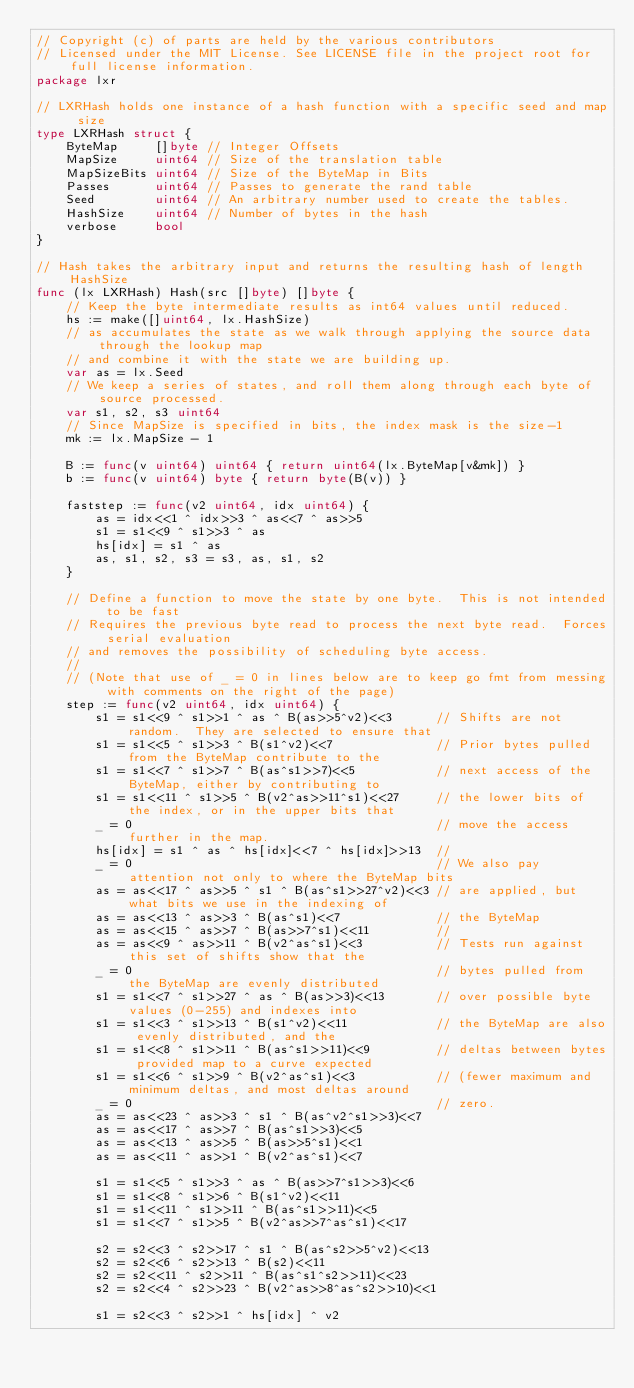Convert code to text. <code><loc_0><loc_0><loc_500><loc_500><_Go_>// Copyright (c) of parts are held by the various contributors
// Licensed under the MIT License. See LICENSE file in the project root for full license information.
package lxr

// LXRHash holds one instance of a hash function with a specific seed and map size
type LXRHash struct {
	ByteMap     []byte // Integer Offsets
	MapSize     uint64 // Size of the translation table
	MapSizeBits uint64 // Size of the ByteMap in Bits
	Passes      uint64 // Passes to generate the rand table
	Seed        uint64 // An arbitrary number used to create the tables.
	HashSize    uint64 // Number of bytes in the hash
	verbose     bool
}

// Hash takes the arbitrary input and returns the resulting hash of length HashSize
func (lx LXRHash) Hash(src []byte) []byte {
	// Keep the byte intermediate results as int64 values until reduced.
	hs := make([]uint64, lx.HashSize)
	// as accumulates the state as we walk through applying the source data through the lookup map
	// and combine it with the state we are building up.
	var as = lx.Seed
	// We keep a series of states, and roll them along through each byte of source processed.
	var s1, s2, s3 uint64
	// Since MapSize is specified in bits, the index mask is the size-1
	mk := lx.MapSize - 1

	B := func(v uint64) uint64 { return uint64(lx.ByteMap[v&mk]) }
	b := func(v uint64) byte { return byte(B(v)) }

	faststep := func(v2 uint64, idx uint64) {
		as = idx<<1 ^ idx>>3 ^ as<<7 ^ as>>5
		s1 = s1<<9 ^ s1>>3 ^ as
		hs[idx] = s1 ^ as
		as, s1, s2, s3 = s3, as, s1, s2
	}

	// Define a function to move the state by one byte.  This is not intended to be fast
	// Requires the previous byte read to process the next byte read.  Forces serial evaluation
	// and removes the possibility of scheduling byte access.
	//
	// (Note that use of _ = 0 in lines below are to keep go fmt from messing with comments on the right of the page)
	step := func(v2 uint64, idx uint64) {
		s1 = s1<<9 ^ s1>>1 ^ as ^ B(as>>5^v2)<<3      // Shifts are not random.  They are selected to ensure that
		s1 = s1<<5 ^ s1>>3 ^ B(s1^v2)<<7              // Prior bytes pulled from the ByteMap contribute to the
		s1 = s1<<7 ^ s1>>7 ^ B(as^s1>>7)<<5           // next access of the ByteMap, either by contributing to
		s1 = s1<<11 ^ s1>>5 ^ B(v2^as>>11^s1)<<27     // the lower bits of the index, or in the upper bits that
		_ = 0                                         // move the access further in the map.
		hs[idx] = s1 ^ as ^ hs[idx]<<7 ^ hs[idx]>>13  //
		_ = 0                                         // We also pay attention not only to where the ByteMap bits
		as = as<<17 ^ as>>5 ^ s1 ^ B(as^s1>>27^v2)<<3 // are applied, but what bits we use in the indexing of
		as = as<<13 ^ as>>3 ^ B(as^s1)<<7             // the ByteMap
		as = as<<15 ^ as>>7 ^ B(as>>7^s1)<<11         //
		as = as<<9 ^ as>>11 ^ B(v2^as^s1)<<3          // Tests run against this set of shifts show that the
		_ = 0                                         // bytes pulled from the ByteMap are evenly distributed
		s1 = s1<<7 ^ s1>>27 ^ as ^ B(as>>3)<<13       // over possible byte values (0-255) and indexes into
		s1 = s1<<3 ^ s1>>13 ^ B(s1^v2)<<11            // the ByteMap are also evenly distributed, and the
		s1 = s1<<8 ^ s1>>11 ^ B(as^s1>>11)<<9         // deltas between bytes provided map to a curve expected
		s1 = s1<<6 ^ s1>>9 ^ B(v2^as^s1)<<3           // (fewer maximum and minimum deltas, and most deltas around
		_ = 0                                         // zero.
		as = as<<23 ^ as>>3 ^ s1 ^ B(as^v2^s1>>3)<<7
		as = as<<17 ^ as>>7 ^ B(as^s1>>3)<<5
		as = as<<13 ^ as>>5 ^ B(as>>5^s1)<<1
		as = as<<11 ^ as>>1 ^ B(v2^as^s1)<<7

		s1 = s1<<5 ^ s1>>3 ^ as ^ B(as>>7^s1>>3)<<6
		s1 = s1<<8 ^ s1>>6 ^ B(s1^v2)<<11
		s1 = s1<<11 ^ s1>>11 ^ B(as^s1>>11)<<5
		s1 = s1<<7 ^ s1>>5 ^ B(v2^as>>7^as^s1)<<17

		s2 = s2<<3 ^ s2>>17 ^ s1 ^ B(as^s2>>5^v2)<<13
		s2 = s2<<6 ^ s2>>13 ^ B(s2)<<11
		s2 = s2<<11 ^ s2>>11 ^ B(as^s1^s2>>11)<<23
		s2 = s2<<4 ^ s2>>23 ^ B(v2^as>>8^as^s2>>10)<<1

		s1 = s2<<3 ^ s2>>1 ^ hs[idx] ^ v2</code> 